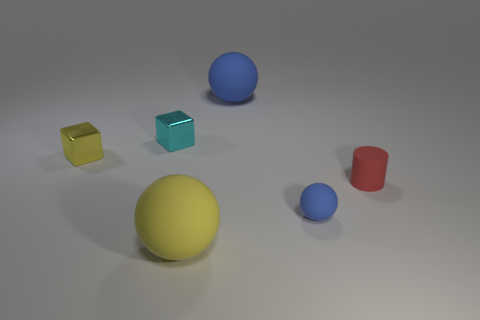Subtract all tiny rubber spheres. How many spheres are left? 2 Add 2 tiny red rubber objects. How many objects exist? 8 Subtract all yellow blocks. How many blocks are left? 1 Subtract all cubes. How many objects are left? 4 Subtract 0 gray cubes. How many objects are left? 6 Subtract 1 cylinders. How many cylinders are left? 0 Subtract all gray cylinders. Subtract all gray cubes. How many cylinders are left? 1 Subtract all blue cylinders. How many yellow blocks are left? 1 Subtract all metallic cubes. Subtract all blue things. How many objects are left? 2 Add 1 blocks. How many blocks are left? 3 